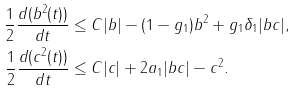Convert formula to latex. <formula><loc_0><loc_0><loc_500><loc_500>\frac { 1 } { 2 } \frac { d ( b ^ { 2 } ( t ) ) } { d t } & \leq C | b | - ( 1 - g _ { 1 } ) b ^ { 2 } + g _ { 1 } \delta _ { 1 } | b c | , \\ \frac { 1 } { 2 } \frac { d ( c ^ { 2 } ( t ) ) } { d t } & \leq C | c | + 2 a _ { 1 } | b c | - c ^ { 2 } .</formula> 